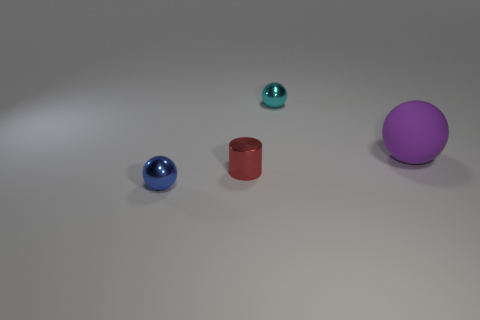Add 3 tiny cubes. How many objects exist? 7 Subtract all tiny balls. How many balls are left? 1 Subtract all blue balls. How many balls are left? 2 Subtract all cyan cylinders. How many yellow balls are left? 0 Subtract all large metallic cylinders. Subtract all large matte balls. How many objects are left? 3 Add 2 large balls. How many large balls are left? 3 Add 2 big blue cylinders. How many big blue cylinders exist? 2 Subtract 0 yellow balls. How many objects are left? 4 Subtract all balls. How many objects are left? 1 Subtract 2 balls. How many balls are left? 1 